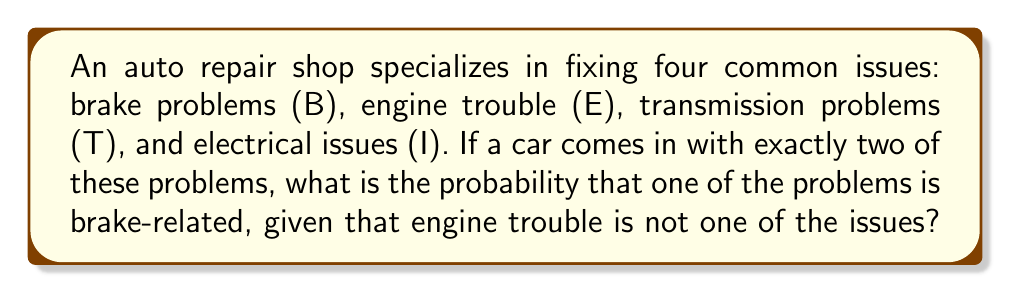Can you answer this question? Let's approach this step-by-step:

1) First, we need to determine the total number of ways to choose 2 issues out of 4. This is a combination problem, denoted as $\binom{4}{2}$ or $C(4,2)$.

   $\binom{4}{2} = \frac{4!}{2!(4-2)!} = \frac{4 \cdot 3}{2 \cdot 1} = 6$

2) The possible combinations are:
   BE, BT, BI, ET, EI, TI

3) Now, we're given that engine trouble (E) is not one of the issues. This eliminates BE, ET, and EI, leaving us with:
   BT, BI, TI

4) Out of these remaining 3 combinations, 2 include brake problems (B).

5) Therefore, the probability is:

   $P(\text{Brake problem | No engine trouble}) = \frac{\text{Favorable outcomes}}{\text{Total outcomes}} = \frac{2}{3}$
Answer: $\frac{2}{3}$ 